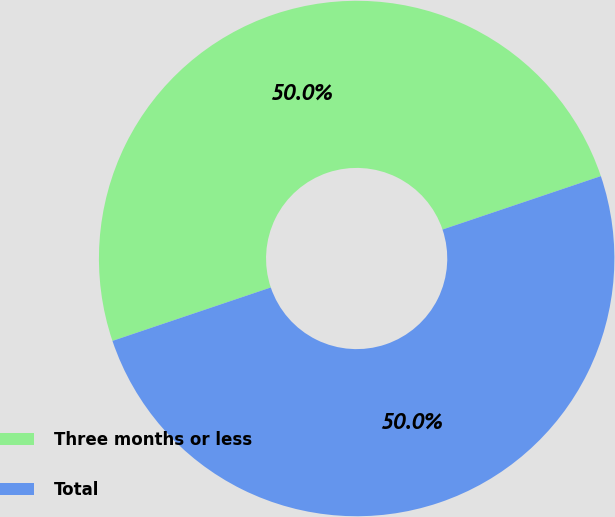Convert chart. <chart><loc_0><loc_0><loc_500><loc_500><pie_chart><fcel>Three months or less<fcel>Total<nl><fcel>50.0%<fcel>50.0%<nl></chart> 